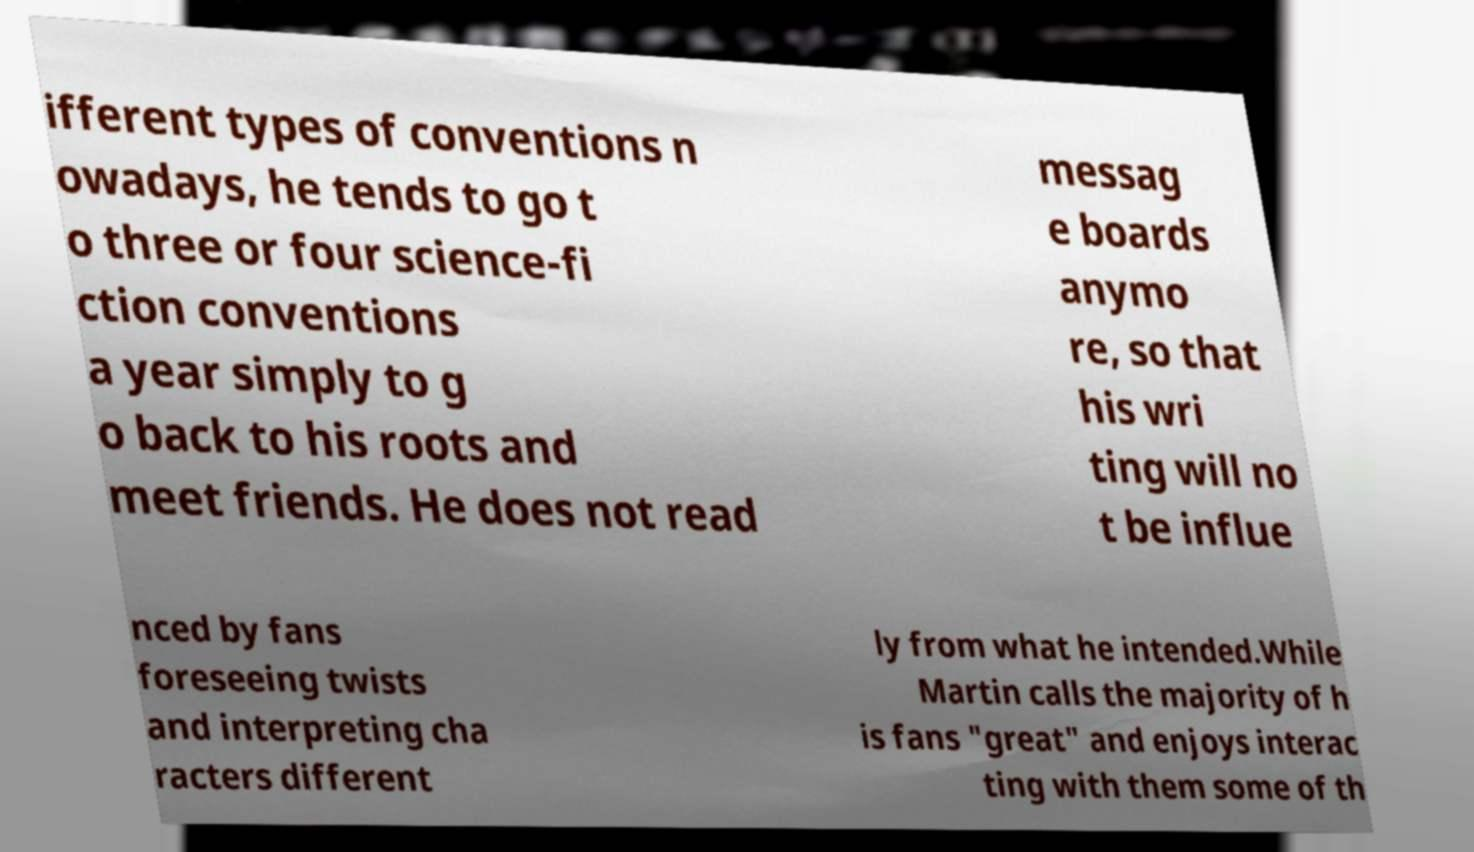I need the written content from this picture converted into text. Can you do that? ifferent types of conventions n owadays, he tends to go t o three or four science-fi ction conventions a year simply to g o back to his roots and meet friends. He does not read messag e boards anymo re, so that his wri ting will no t be influe nced by fans foreseeing twists and interpreting cha racters different ly from what he intended.While Martin calls the majority of h is fans "great" and enjoys interac ting with them some of th 